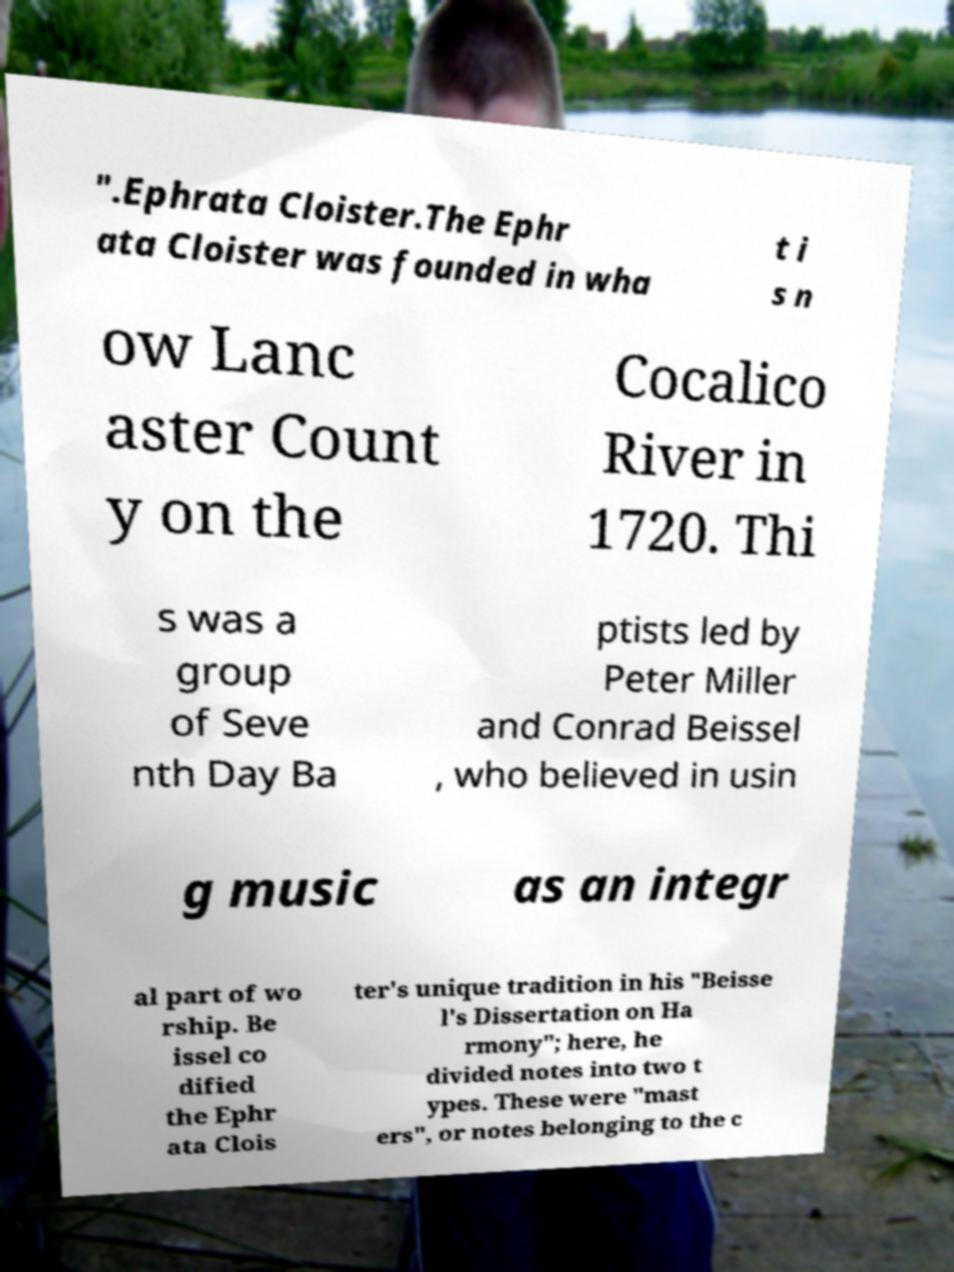Could you assist in decoding the text presented in this image and type it out clearly? ".Ephrata Cloister.The Ephr ata Cloister was founded in wha t i s n ow Lanc aster Count y on the Cocalico River in 1720. Thi s was a group of Seve nth Day Ba ptists led by Peter Miller and Conrad Beissel , who believed in usin g music as an integr al part of wo rship. Be issel co dified the Ephr ata Clois ter's unique tradition in his "Beisse l's Dissertation on Ha rmony"; here, he divided notes into two t ypes. These were "mast ers", or notes belonging to the c 